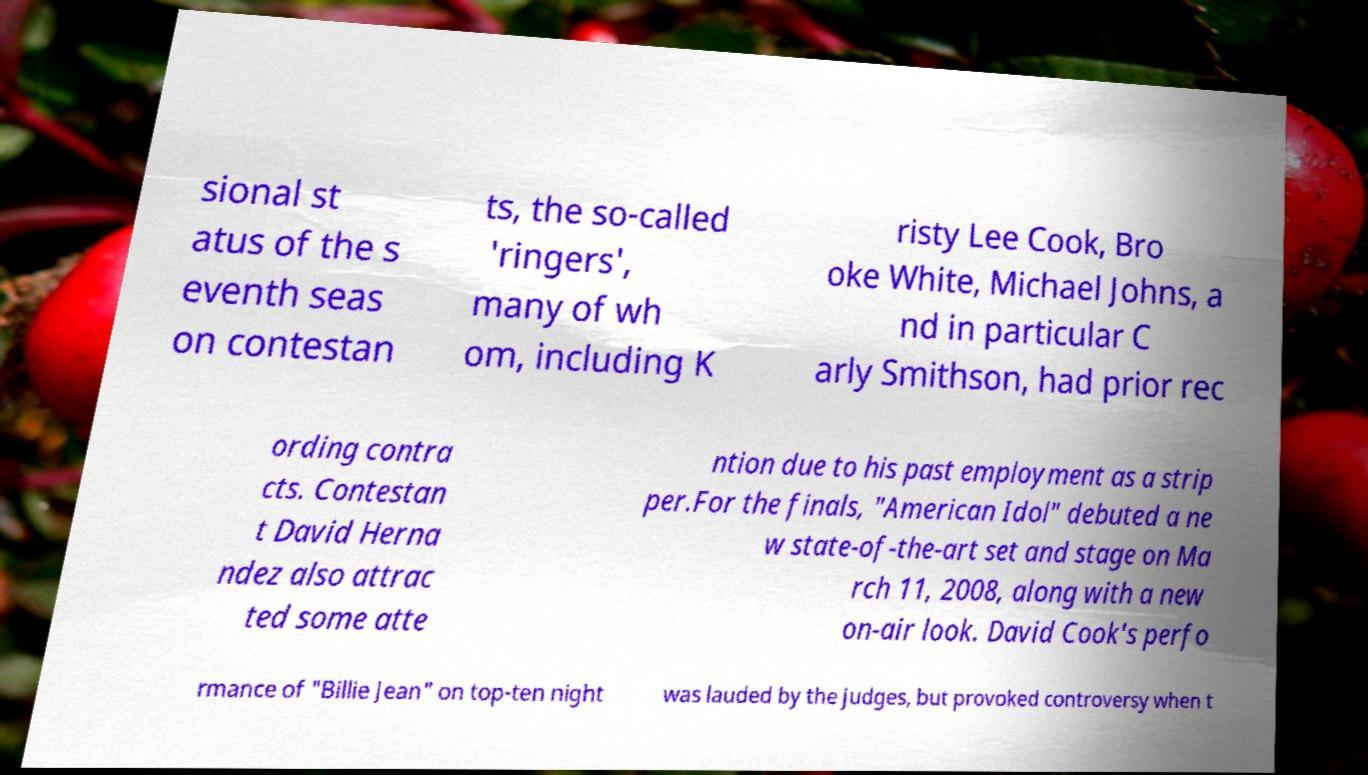Please identify and transcribe the text found in this image. sional st atus of the s eventh seas on contestan ts, the so-called 'ringers', many of wh om, including K risty Lee Cook, Bro oke White, Michael Johns, a nd in particular C arly Smithson, had prior rec ording contra cts. Contestan t David Herna ndez also attrac ted some atte ntion due to his past employment as a strip per.For the finals, "American Idol" debuted a ne w state-of-the-art set and stage on Ma rch 11, 2008, along with a new on-air look. David Cook's perfo rmance of "Billie Jean" on top-ten night was lauded by the judges, but provoked controversy when t 